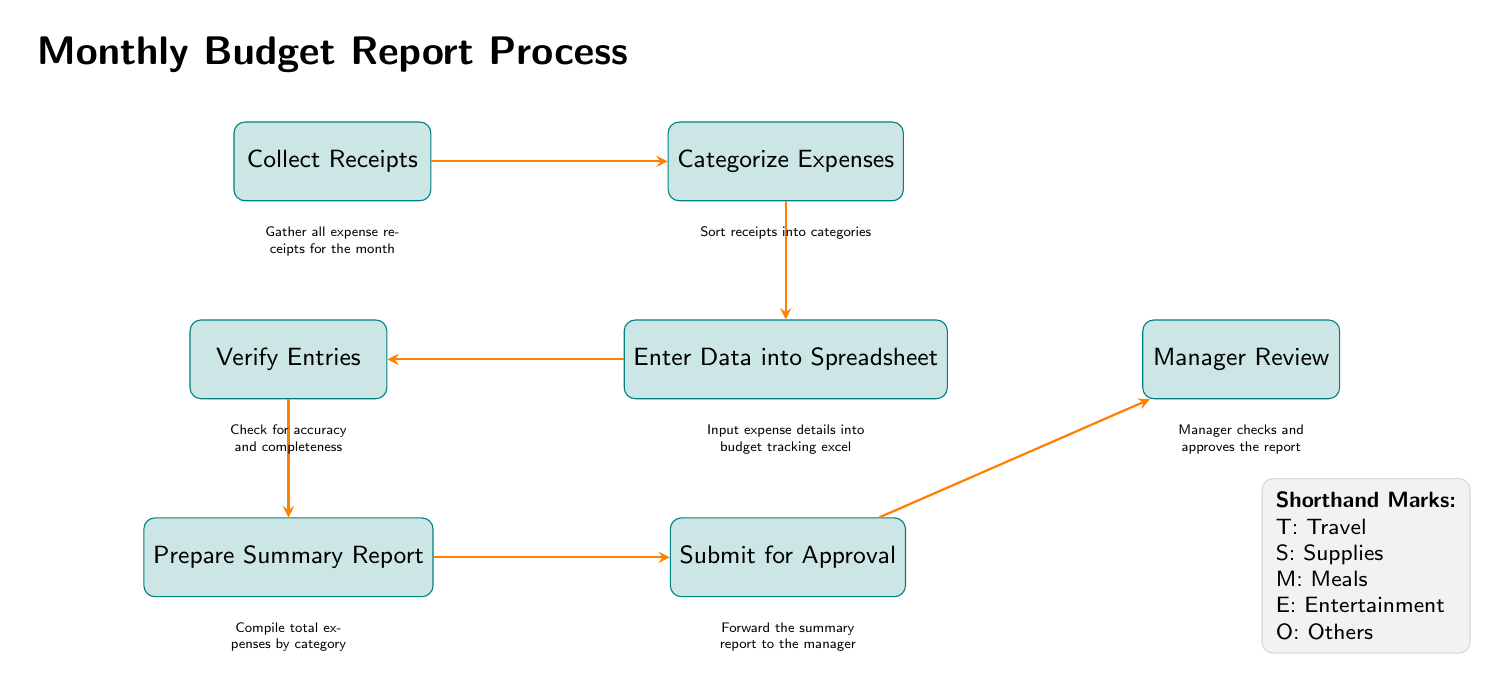What is the first step in the process? The diagram clearly labels the first process step as "Collect Receipts," which is indicated at the top left of the flow.
Answer: Collect Receipts How many total steps are there? By counting the distinct process nodes in the flowchart, we find there are six steps: Collect Receipts, Categorize Expenses, Enter Data into Spreadsheet, Verify Entries, Prepare Summary Report, and Submit for Approval.
Answer: Six What is the last step before the manager review? The diagram shows that the step preceding "Manager Review" is "Submit for Approval," directly connected to it in the flow.
Answer: Submit for Approval What do the shorthand marks represent? The legend at the bottom right defines the shorthand marks: T for Travel, S for Supplies, M for Meals, E for Entertainment, and O for Others.
Answer: Travel, Supplies, Meals, Entertainment, Others Which step involves checking for accuracy? The step that involves checking for accuracy is labeled "Verify Entries," located to the left of "Enter Data into Spreadsheet."
Answer: Verify Entries What is the purpose of the "Prepare Summary Report" step? The explanation beneath the "Prepare Summary Report" node states that this step is for compiling total expenses by category, indicating its role in summarizing financial information.
Answer: Compile total expenses by category How is the final approval obtained? The process for final approval occurs after the "Submit for Approval" step, where the "Manager Review" takes place, indicating that the manager checks and approves the submitted report.
Answer: Manager checks and approves the report In which step is the expense data entered into a system? The node labeled "Enter Data into Spreadsheet" indicates this step is where expense details are input into a budget tracking excel, confirming the action.
Answer: Enter Data into Spreadsheet What step comes after categorizing expenses? The flow shows that after "Categorize Expenses," the subsequent step is "Enter Data into Spreadsheet," which demonstrates the sequence of tasks in the budget report process.
Answer: Enter Data into Spreadsheet 